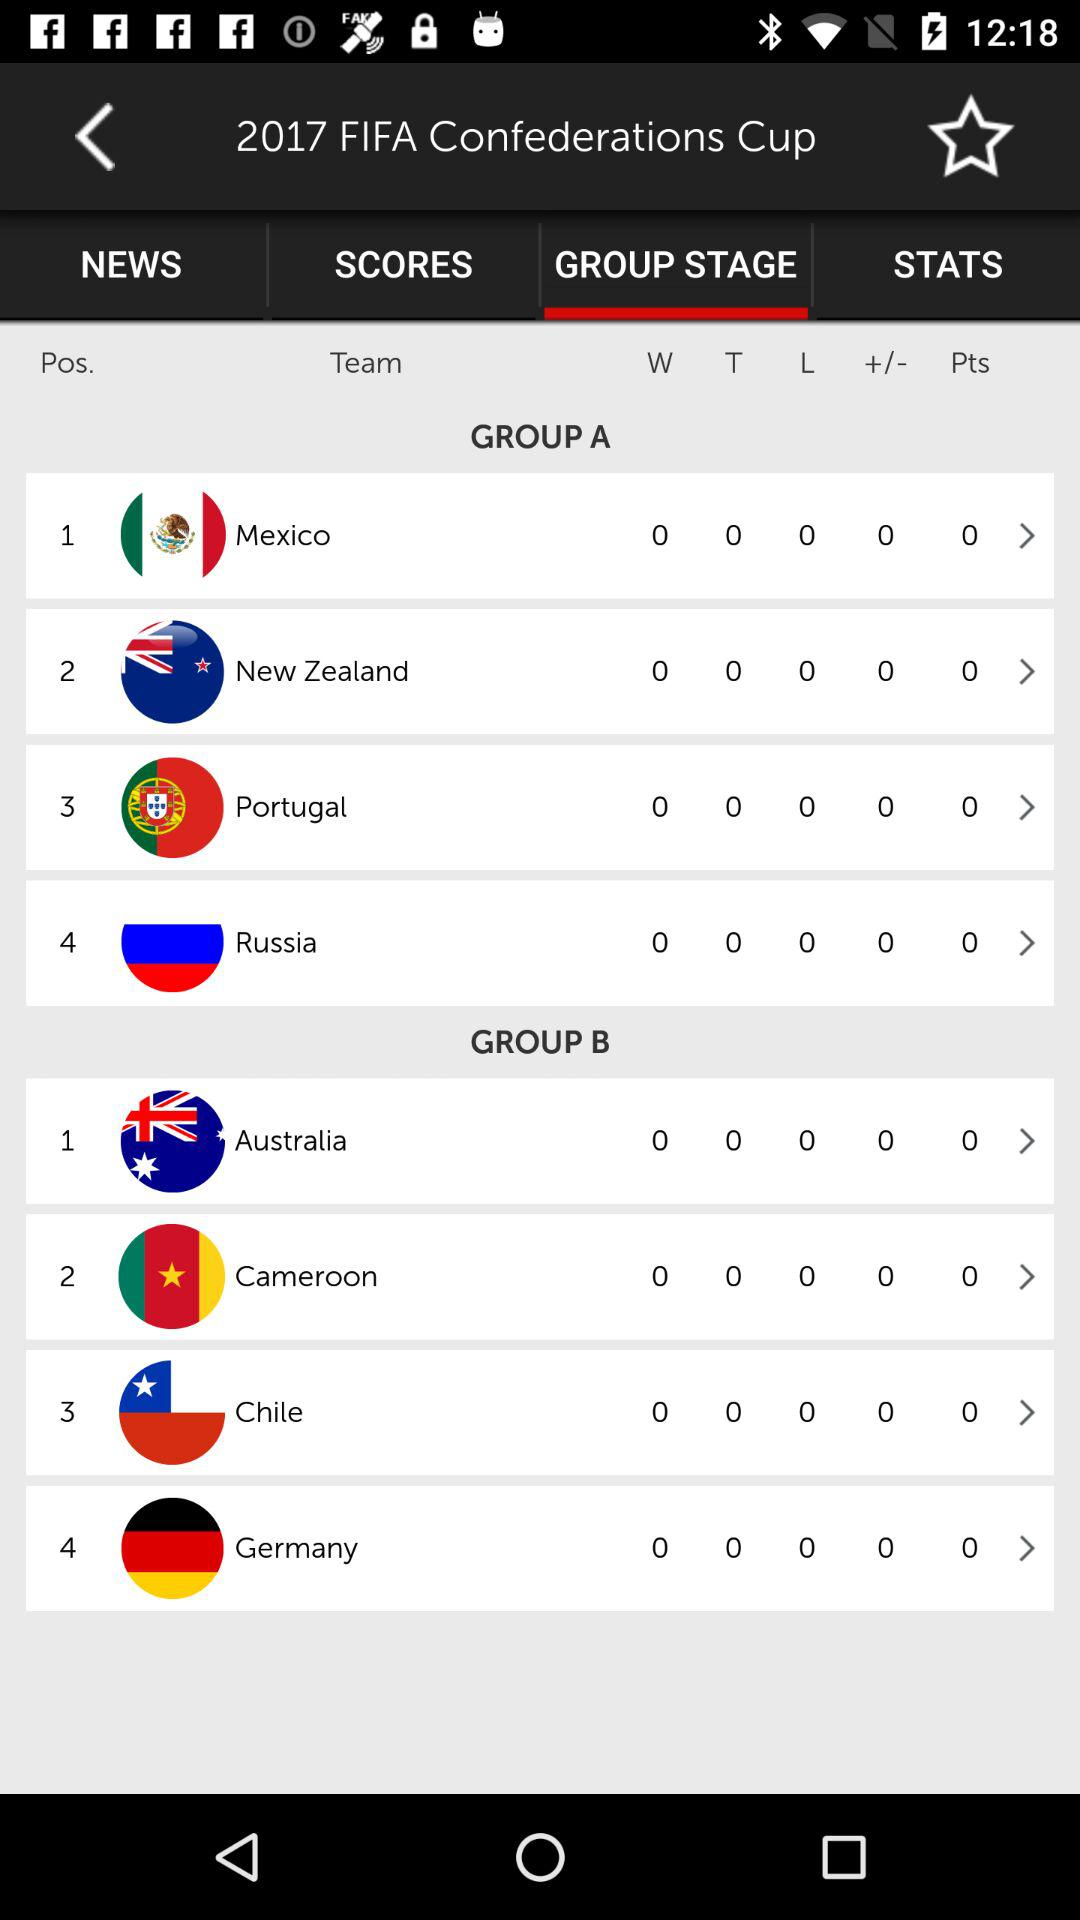How many reviews are there?
When the provided information is insufficient, respond with <no answer>. <no answer> 